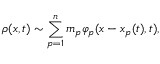Convert formula to latex. <formula><loc_0><loc_0><loc_500><loc_500>\rho ( x , t ) \sim \sum _ { p = 1 } ^ { n } m _ { p } \varphi _ { p } ( x - x _ { p } ( t ) , t ) ,</formula> 